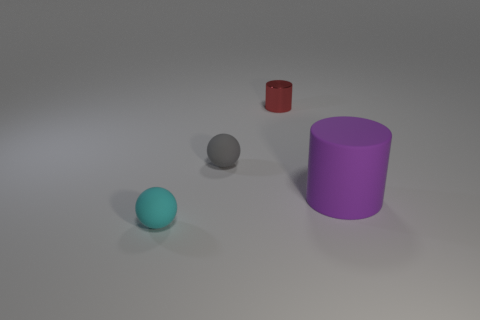The cyan thing is what shape?
Offer a terse response. Sphere. What is the material of the small sphere that is to the left of the gray matte sphere?
Your answer should be compact. Rubber. How big is the rubber object on the left side of the matte object behind the matte thing that is to the right of the tiny red metal object?
Give a very brief answer. Small. Does the small ball right of the tiny cyan ball have the same material as the cylinder that is in front of the shiny cylinder?
Ensure brevity in your answer.  Yes. What number of other things are there of the same color as the shiny thing?
Your answer should be compact. 0. How many objects are either tiny objects that are behind the tiny gray sphere or tiny things left of the small metallic cylinder?
Provide a succinct answer. 3. There is a rubber ball on the right side of the tiny thing in front of the purple matte object; what is its size?
Ensure brevity in your answer.  Small. What is the size of the matte cylinder?
Your answer should be very brief. Large. Is the color of the small matte object to the right of the cyan rubber ball the same as the small rubber thing in front of the purple rubber thing?
Provide a succinct answer. No. What number of other objects are the same material as the large thing?
Your response must be concise. 2. 